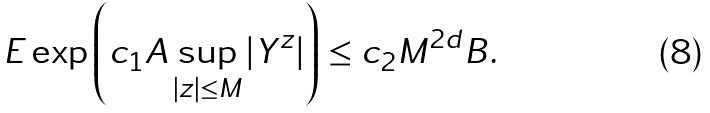<formula> <loc_0><loc_0><loc_500><loc_500>E \exp \left ( c _ { 1 } A \sup _ { | z | \leq M } | Y ^ { z } | \right ) \leq c _ { 2 } M ^ { 2 d } B .</formula> 